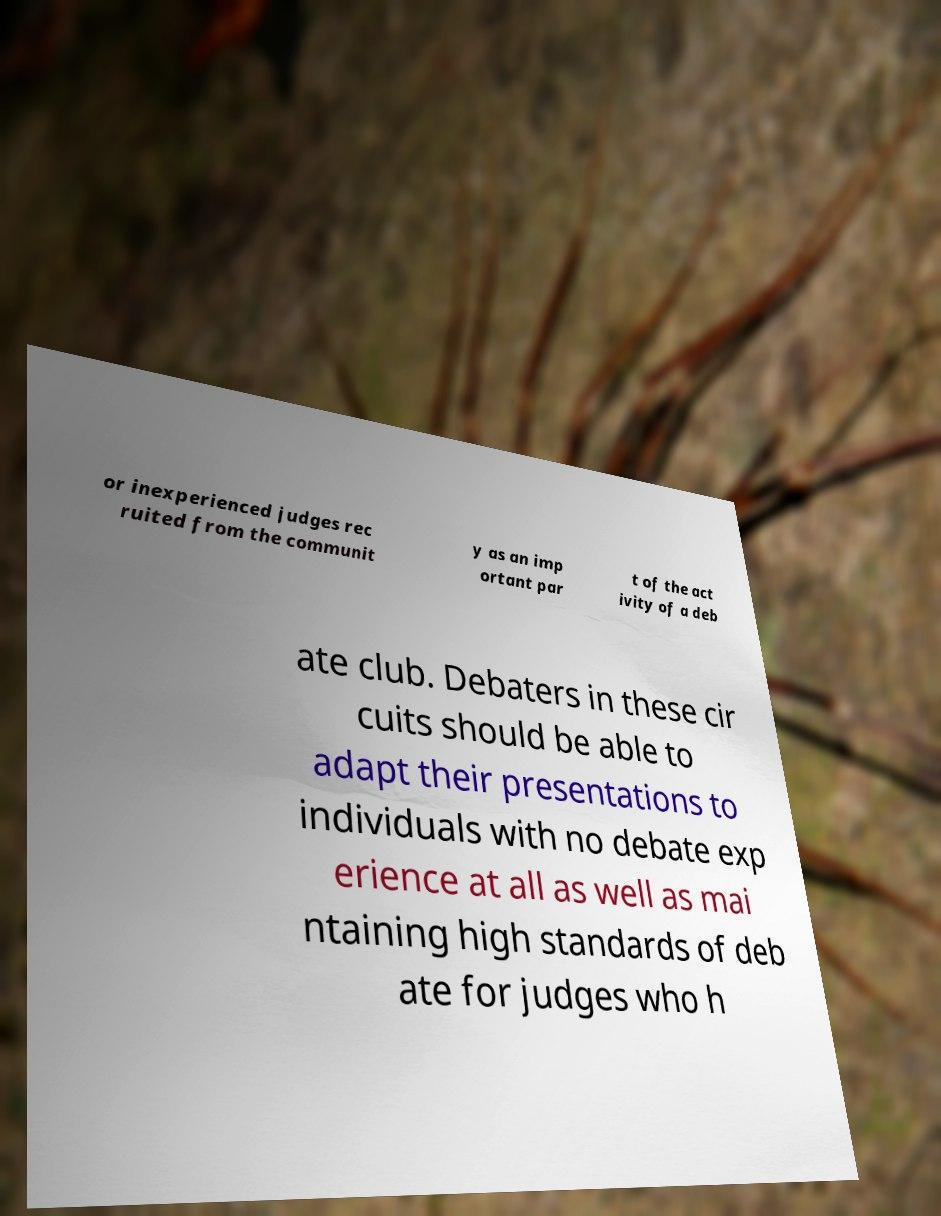Can you accurately transcribe the text from the provided image for me? or inexperienced judges rec ruited from the communit y as an imp ortant par t of the act ivity of a deb ate club. Debaters in these cir cuits should be able to adapt their presentations to individuals with no debate exp erience at all as well as mai ntaining high standards of deb ate for judges who h 